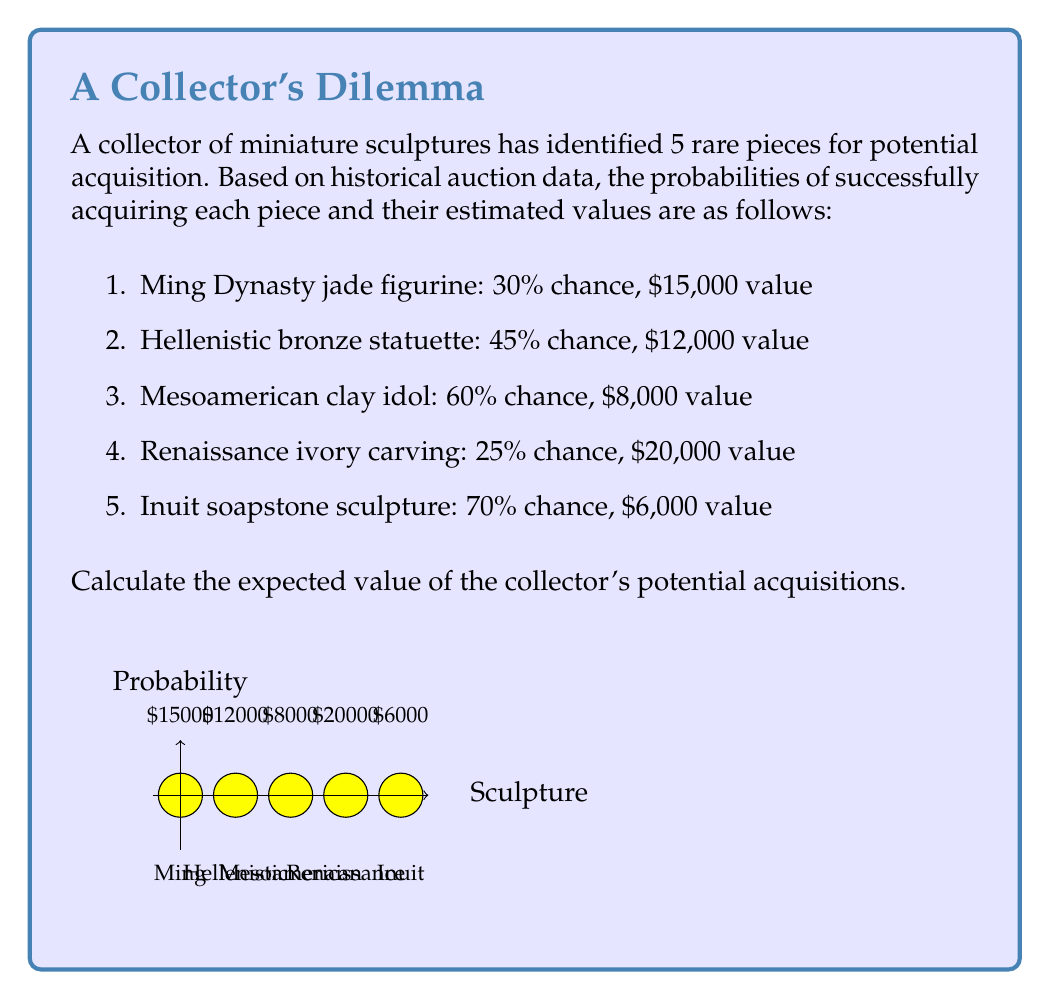Help me with this question. To calculate the expected value of the potential acquisitions, we need to:

1. Calculate the expected value for each sculpture
2. Sum these individual expected values

The expected value for each sculpture is given by:

$E(\text{sculpture}) = P(\text{acquisition}) \times \text{Value}$

Let's calculate for each sculpture:

1. Ming Dynasty jade figurine:
   $E_1 = 0.30 \times \$15,000 = \$4,500$

2. Hellenistic bronze statuette:
   $E_2 = 0.45 \times \$12,000 = \$5,400$

3. Mesoamerican clay idol:
   $E_3 = 0.60 \times \$8,000 = \$4,800$

4. Renaissance ivory carving:
   $E_4 = 0.25 \times \$20,000 = \$5,000$

5. Inuit soapstone sculpture:
   $E_5 = 0.70 \times \$6,000 = \$4,200$

Now, we sum these individual expected values:

$$\begin{align}
E(\text{total}) &= E_1 + E_2 + E_3 + E_4 + E_5 \\
&= \$4,500 + \$5,400 + \$4,800 + \$5,000 + \$4,200 \\
&= \$23,900
\end{align}$$

Therefore, the expected value of the collector's potential acquisitions is $23,900.
Answer: $23,900 